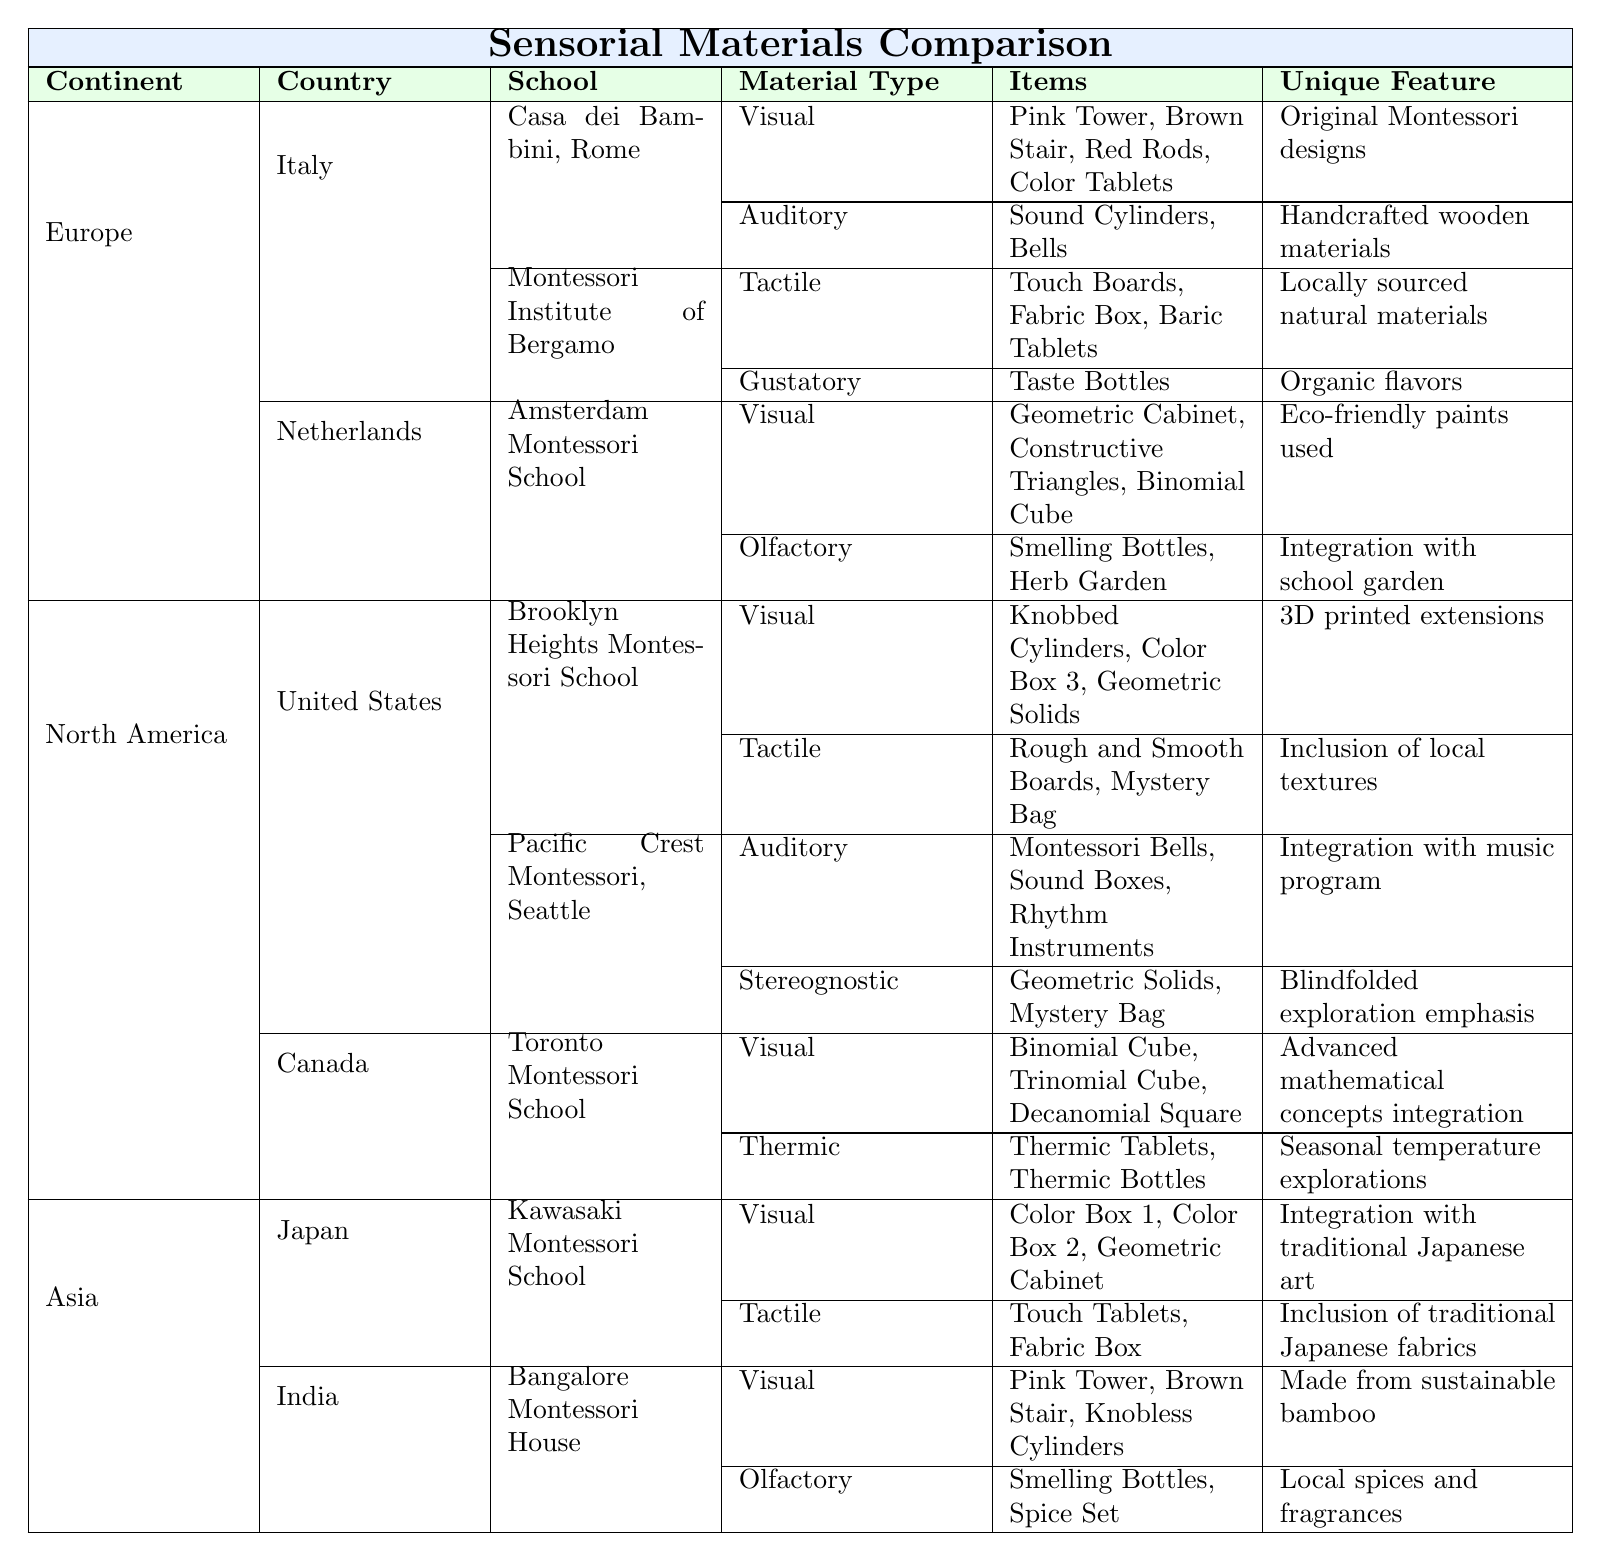What visual materials are used in the Casa dei Bambini in Rome? The table lists 'Visual' materials for the Casa dei Bambini, which are the Pink Tower, Brown Stair, Red Rods, and Color Tablets.
Answer: Pink Tower, Brown Stair, Red Rods, Color Tablets Which type of materials does the Montessori Institute of Bergamo utilize for tactile learning? The table indicates that the Montessori Institute of Bergamo uses Touch Boards, Fabric Box, and Baric Tablets as tactile materials.
Answer: Touch Boards, Fabric Box, Baric Tablets How many schools in the United States incorporate auditory materials? The table shows two schools in the United States (Brooklyn Heights Montessori School and Pacific Crest Montessori) that include auditory materials.
Answer: 2 Is the Pink Tower included in the sensorial materials of both Italy and India? Yes, the Pink Tower is listed for both the Casa dei Bambini in Italy and the Bangalore Montessori House in India.
Answer: Yes What unique feature distinguishes the auditory materials at Pacific Crest Montessori? The unique feature for the auditory materials at Pacific Crest Montessori is the integration with the music program.
Answer: Integration with music program Which continent has the highest representation of countries in this table? By counting the number of countries listed, Europe has 2 (Italy and Netherlands), North America has 2 (United States and Canada), and Asia has 2 (Japan and India). All continents have equal representation with 2 countries each.
Answer: Equal representation What is the total number of unique visual items listed across Montessori schools in Italy? For Italy, the unique visual materials listed are Pink Tower, Brown Stair, Red Rods, Color Tablets, Geometric Cabinet, Constructive Triangles, and Binomial Cube. Counting these gives a total of 7 unique visual items.
Answer: 7 Which school has the unique feature of using locally sourced natural materials? The table indicates that the Montessori Institute of Bergamo utilizes locally sourced natural materials for their tactile materials.
Answer: Montessori Institute of Bergamo What materials are classified as olfactory in the Montessori schools from Asia? The table shows that for both Kawasaki Montessori School (Japan) and Bangalore Montessori House (India), the olfactory materials are Smelling Bottles, Herb Garden and Smelling Bottles, Spice Set, respectively.
Answer: Smelling Bottles, Herb Garden; Smelling Bottles, Spice Set Identify the school that incorporates traditional Japanese art in their visual materials. The Kawasaki Montessori School in Japan is noted for integrating traditional Japanese art in their visual materials.
Answer: Kawasaki Montessori School 